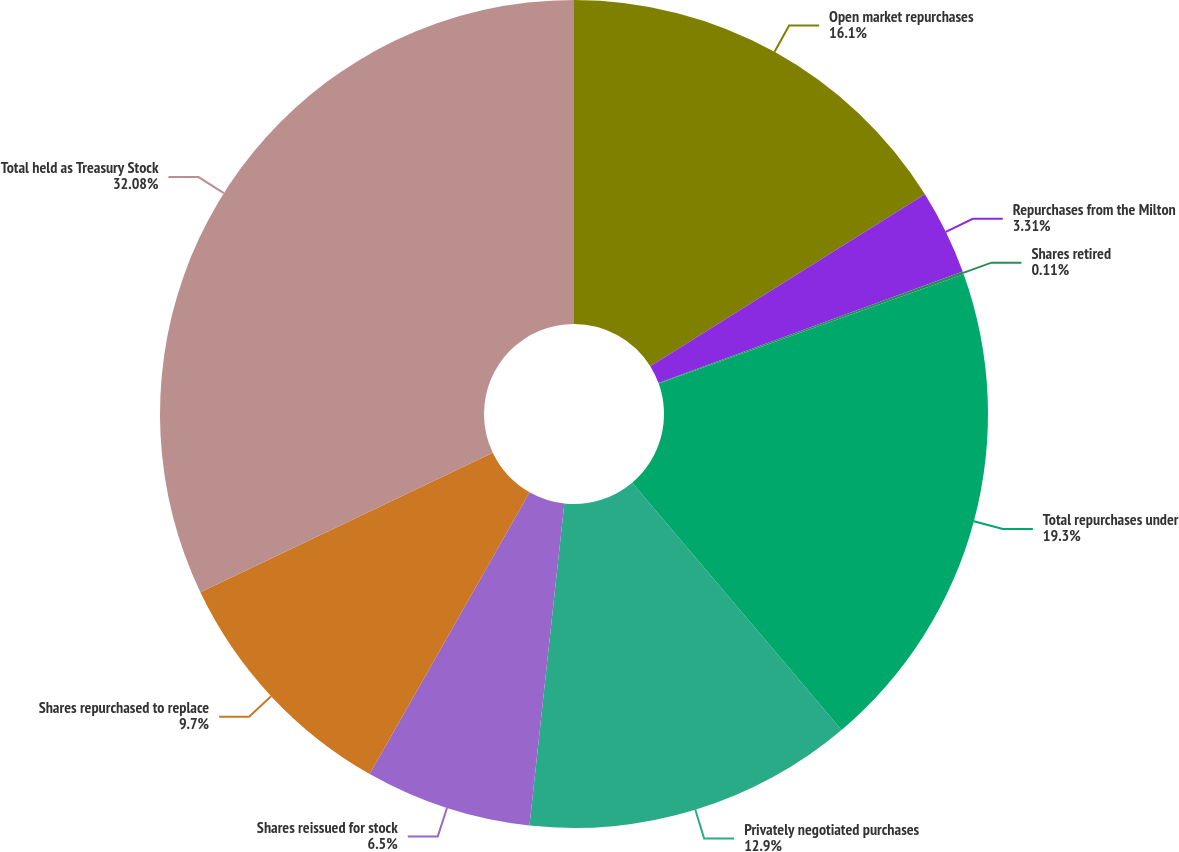Convert chart. <chart><loc_0><loc_0><loc_500><loc_500><pie_chart><fcel>Open market repurchases<fcel>Repurchases from the Milton<fcel>Shares retired<fcel>Total repurchases under<fcel>Privately negotiated purchases<fcel>Shares reissued for stock<fcel>Shares repurchased to replace<fcel>Total held as Treasury Stock<nl><fcel>16.1%<fcel>3.31%<fcel>0.11%<fcel>19.3%<fcel>12.9%<fcel>6.5%<fcel>9.7%<fcel>32.09%<nl></chart> 